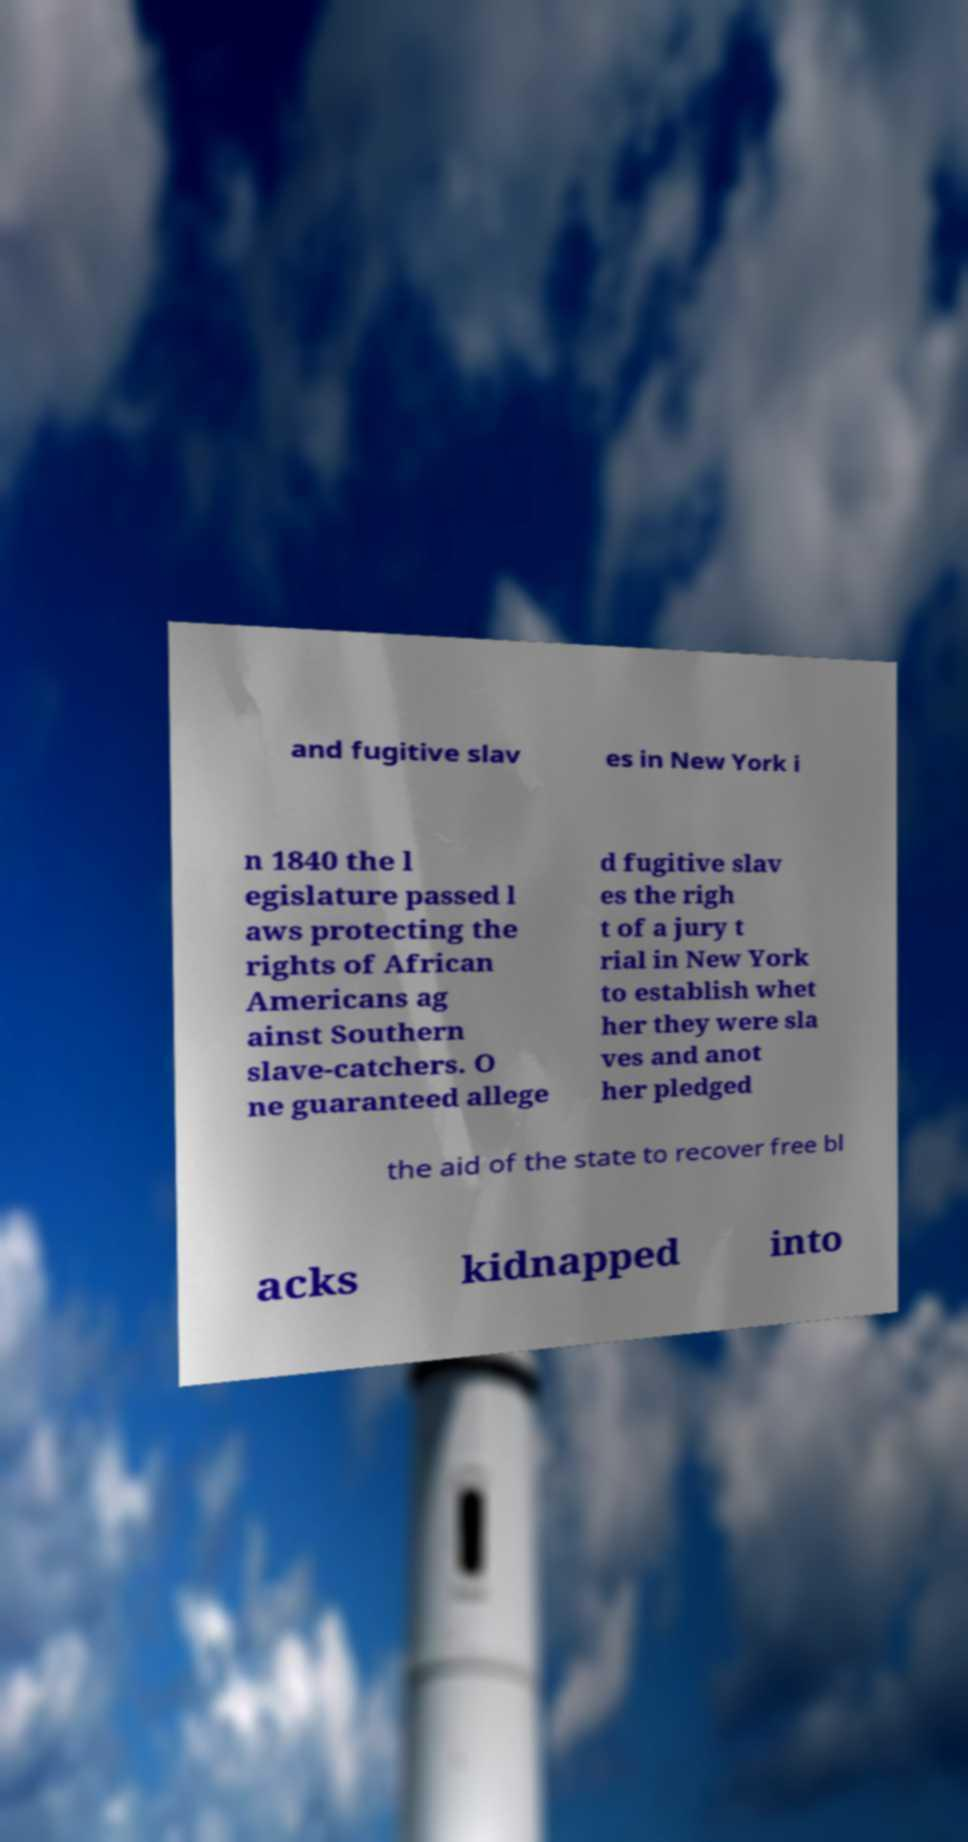Could you assist in decoding the text presented in this image and type it out clearly? and fugitive slav es in New York i n 1840 the l egislature passed l aws protecting the rights of African Americans ag ainst Southern slave-catchers. O ne guaranteed allege d fugitive slav es the righ t of a jury t rial in New York to establish whet her they were sla ves and anot her pledged the aid of the state to recover free bl acks kidnapped into 